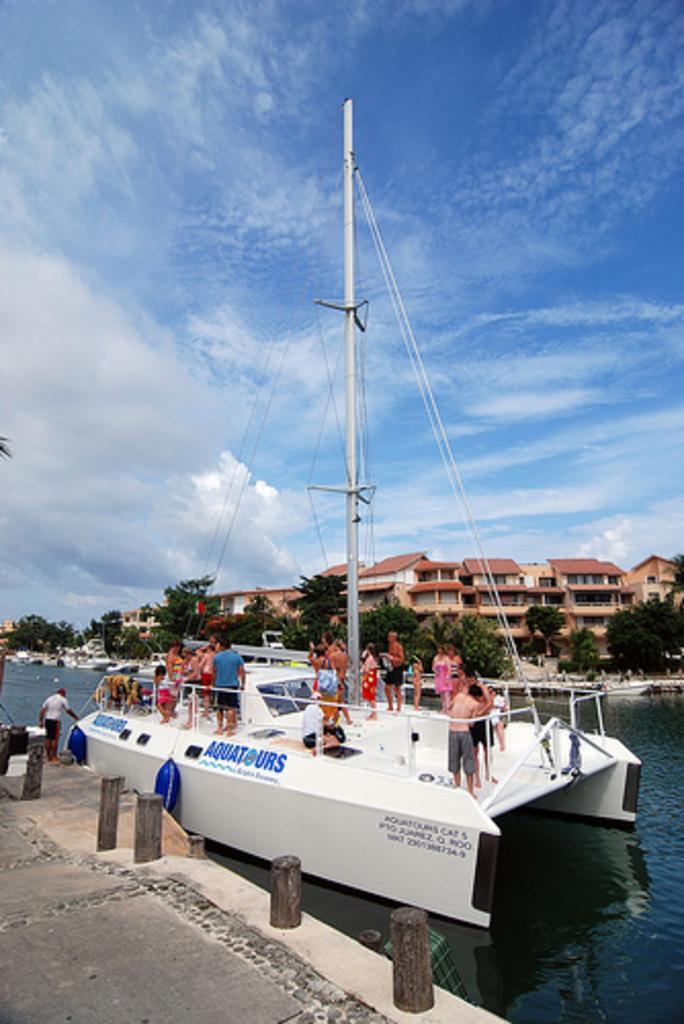Can you describe this image briefly? In this image there is a boat on river, on that boat there are people standing, in the background there are trees houses and the sky. 